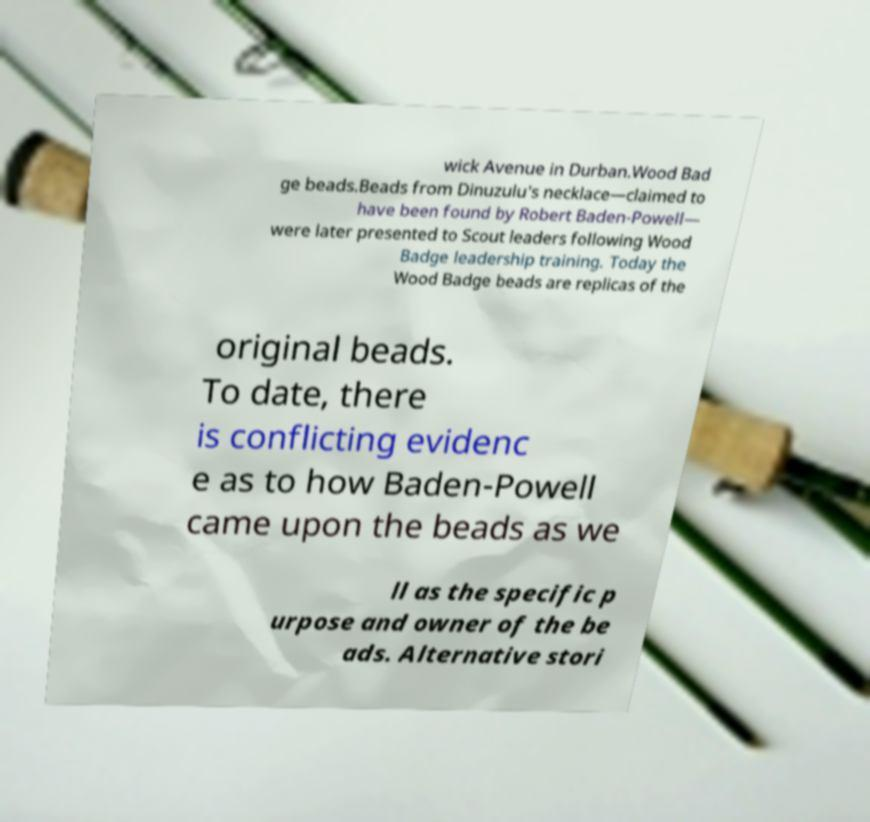Please read and relay the text visible in this image. What does it say? wick Avenue in Durban.Wood Bad ge beads.Beads from Dinuzulu's necklace—claimed to have been found by Robert Baden-Powell— were later presented to Scout leaders following Wood Badge leadership training. Today the Wood Badge beads are replicas of the original beads. To date, there is conflicting evidenc e as to how Baden-Powell came upon the beads as we ll as the specific p urpose and owner of the be ads. Alternative stori 